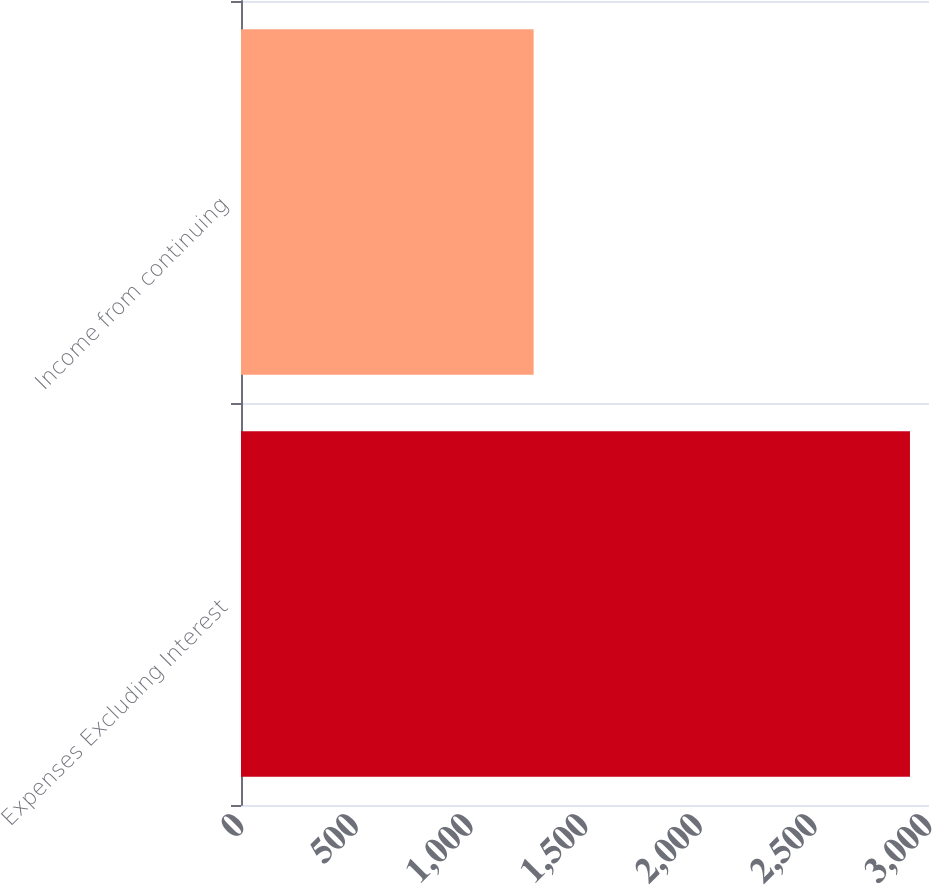Convert chart. <chart><loc_0><loc_0><loc_500><loc_500><bar_chart><fcel>Expenses Excluding Interest<fcel>Income from continuing<nl><fcel>2917<fcel>1276<nl></chart> 